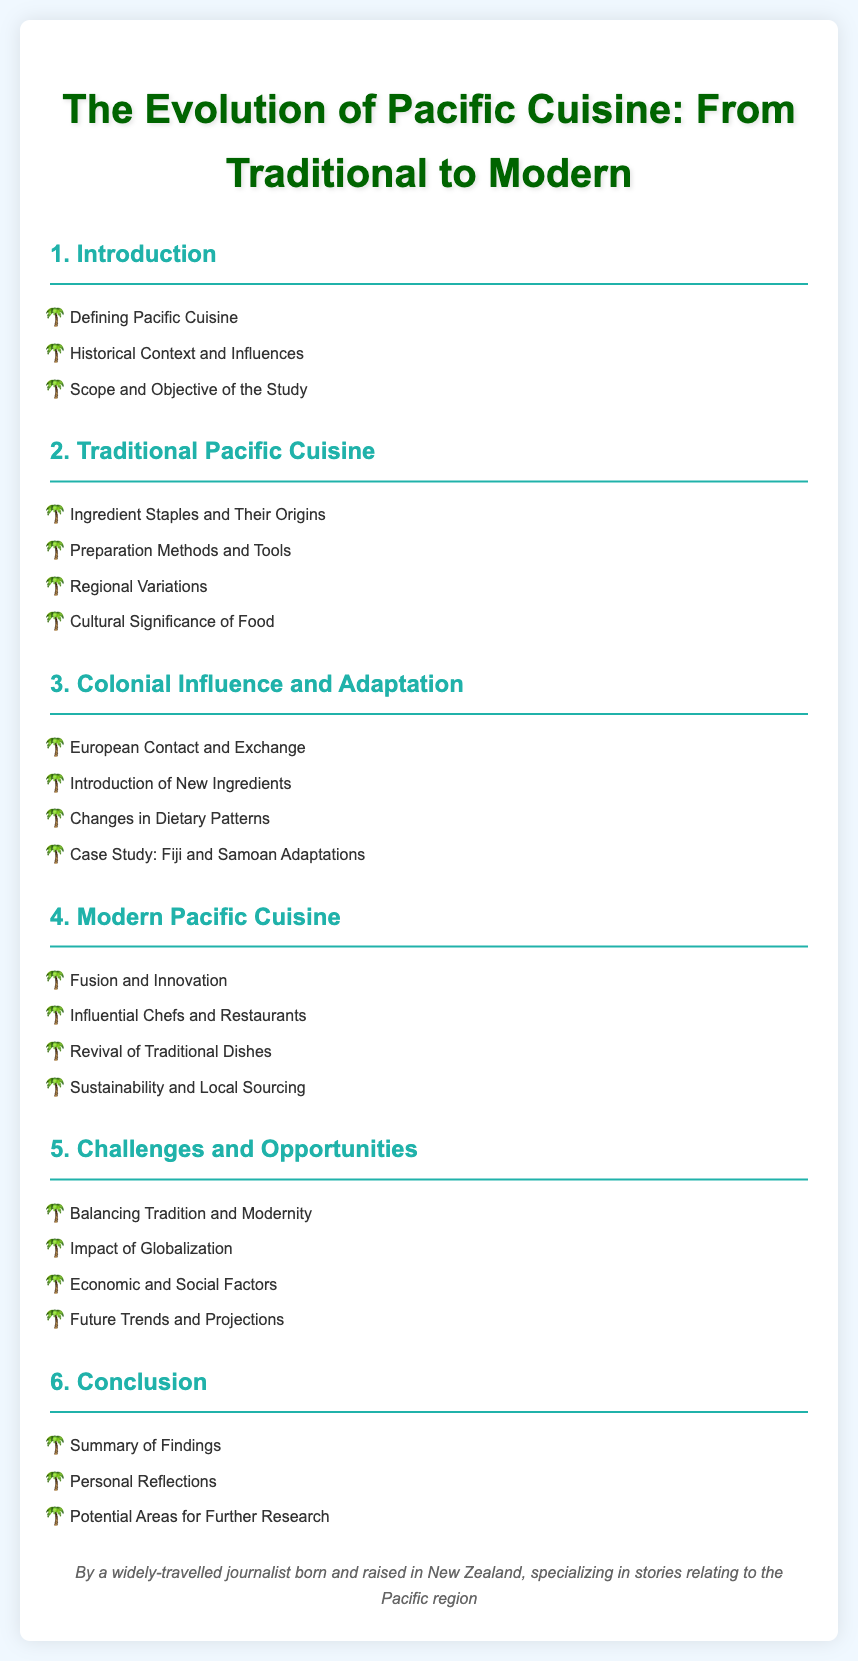What is the title of the document? The title of the document is stated at the top in a prominent header.
Answer: The Evolution of Pacific Cuisine: From Traditional to Modern How many main sections are in the table of contents? The document lists the main sections, which can be counted.
Answer: 6 What is listed under section 2? Section 2 details various aspects of Traditional Pacific Cuisine.
Answer: Ingredient Staples and Their Origins, Preparation Methods and Tools, Regional Variations, Cultural Significance of Food What case study is mentioned in section 3? The document specifies a particular case study related to adaptations in a specific region.
Answer: Fiji and Samoan Adaptations What does section 4 focus on? Section 4 addresses aspects related to the current state of Pacific cuisine.
Answer: Fusion and Innovation, Influential Chefs and Restaurants, Revival of Traditional Dishes, Sustainability and Local Sourcing What challenge is highlighted in section 5? Section 5 mentions difficulties faced in the evolution of Pacific cuisine.
Answer: Balancing Tradition and Modernity 